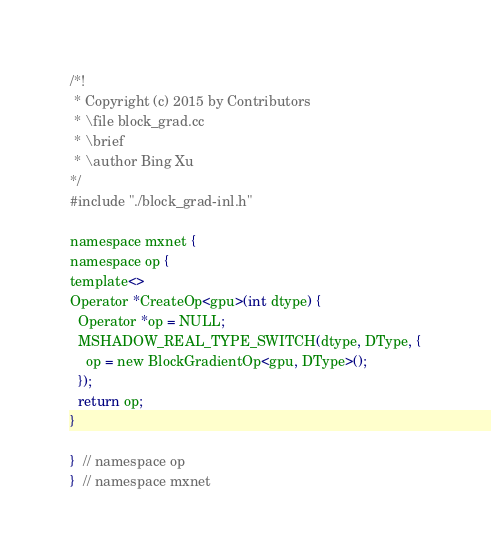<code> <loc_0><loc_0><loc_500><loc_500><_Cuda_>/*!
 * Copyright (c) 2015 by Contributors
 * \file block_grad.cc
 * \brief
 * \author Bing Xu
*/
#include "./block_grad-inl.h"

namespace mxnet {
namespace op {
template<>
Operator *CreateOp<gpu>(int dtype) {
  Operator *op = NULL;
  MSHADOW_REAL_TYPE_SWITCH(dtype, DType, {
    op = new BlockGradientOp<gpu, DType>();
  });
  return op;
}

}  // namespace op
}  // namespace mxnet

</code> 